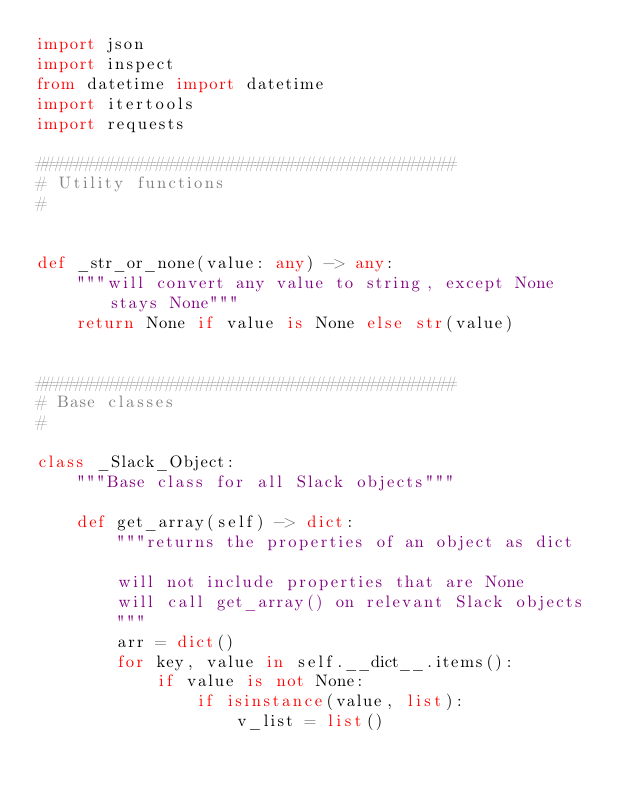Convert code to text. <code><loc_0><loc_0><loc_500><loc_500><_Python_>import json
import inspect
from datetime import datetime
import itertools
import requests

##########################################
# Utility functions
#


def _str_or_none(value: any) -> any:
    """will convert any value to string, except None stays None"""
    return None if value is None else str(value)


##########################################
# Base classes
#

class _Slack_Object:
    """Base class for all Slack objects"""
    
    def get_array(self) -> dict:        
        """returns the properties of an object as dict
        
        will not include properties that are None
        will call get_array() on relevant Slack objects
        """
        arr = dict()
        for key, value in self.__dict__.items():
            if value is not None:
                if isinstance(value, list):
                    v_list = list()</code> 